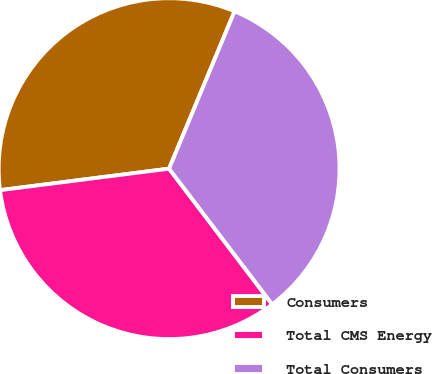<chart> <loc_0><loc_0><loc_500><loc_500><pie_chart><fcel>Consumers<fcel>Total CMS Energy<fcel>Total Consumers<nl><fcel>33.29%<fcel>33.33%<fcel>33.38%<nl></chart> 